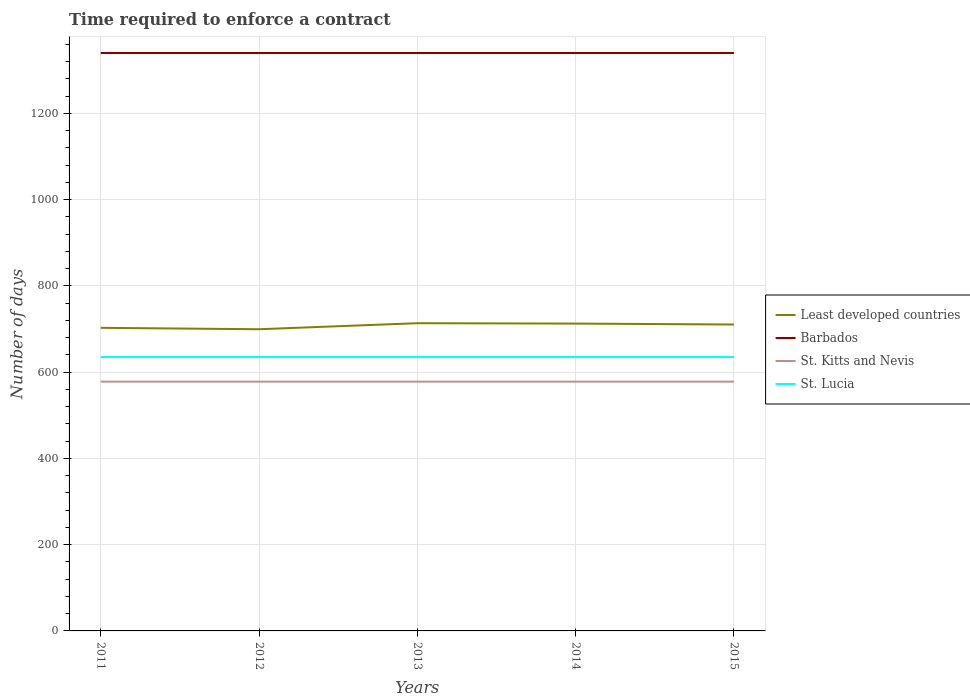How many different coloured lines are there?
Ensure brevity in your answer.  4. Does the line corresponding to St. Lucia intersect with the line corresponding to St. Kitts and Nevis?
Provide a succinct answer. No. Is the number of lines equal to the number of legend labels?
Offer a very short reply. Yes. Across all years, what is the maximum number of days required to enforce a contract in St. Lucia?
Your answer should be very brief. 635. In which year was the number of days required to enforce a contract in St. Lucia maximum?
Provide a short and direct response. 2011. What is the difference between the highest and the second highest number of days required to enforce a contract in St. Kitts and Nevis?
Your answer should be compact. 0. What is the difference between the highest and the lowest number of days required to enforce a contract in St. Lucia?
Offer a terse response. 0. Is the number of days required to enforce a contract in Barbados strictly greater than the number of days required to enforce a contract in St. Kitts and Nevis over the years?
Make the answer very short. No. How many lines are there?
Offer a terse response. 4. How many years are there in the graph?
Your response must be concise. 5. Are the values on the major ticks of Y-axis written in scientific E-notation?
Make the answer very short. No. Does the graph contain grids?
Offer a terse response. Yes. How many legend labels are there?
Offer a terse response. 4. How are the legend labels stacked?
Make the answer very short. Vertical. What is the title of the graph?
Make the answer very short. Time required to enforce a contract. Does "Lesotho" appear as one of the legend labels in the graph?
Make the answer very short. No. What is the label or title of the X-axis?
Give a very brief answer. Years. What is the label or title of the Y-axis?
Make the answer very short. Number of days. What is the Number of days of Least developed countries in 2011?
Your response must be concise. 702.79. What is the Number of days of Barbados in 2011?
Offer a very short reply. 1340. What is the Number of days in St. Kitts and Nevis in 2011?
Provide a short and direct response. 578. What is the Number of days of St. Lucia in 2011?
Ensure brevity in your answer.  635. What is the Number of days in Least developed countries in 2012?
Your response must be concise. 699.53. What is the Number of days in Barbados in 2012?
Provide a short and direct response. 1340. What is the Number of days in St. Kitts and Nevis in 2012?
Make the answer very short. 578. What is the Number of days of St. Lucia in 2012?
Offer a terse response. 635. What is the Number of days in Least developed countries in 2013?
Your answer should be compact. 713.5. What is the Number of days of Barbados in 2013?
Provide a succinct answer. 1340. What is the Number of days in St. Kitts and Nevis in 2013?
Your response must be concise. 578. What is the Number of days of St. Lucia in 2013?
Make the answer very short. 635. What is the Number of days of Least developed countries in 2014?
Offer a terse response. 712.63. What is the Number of days in Barbados in 2014?
Provide a succinct answer. 1340. What is the Number of days in St. Kitts and Nevis in 2014?
Give a very brief answer. 578. What is the Number of days in St. Lucia in 2014?
Ensure brevity in your answer.  635. What is the Number of days of Least developed countries in 2015?
Keep it short and to the point. 710.46. What is the Number of days in Barbados in 2015?
Offer a very short reply. 1340. What is the Number of days in St. Kitts and Nevis in 2015?
Your response must be concise. 578. What is the Number of days in St. Lucia in 2015?
Give a very brief answer. 635. Across all years, what is the maximum Number of days of Least developed countries?
Ensure brevity in your answer.  713.5. Across all years, what is the maximum Number of days of Barbados?
Give a very brief answer. 1340. Across all years, what is the maximum Number of days of St. Kitts and Nevis?
Give a very brief answer. 578. Across all years, what is the maximum Number of days of St. Lucia?
Give a very brief answer. 635. Across all years, what is the minimum Number of days in Least developed countries?
Give a very brief answer. 699.53. Across all years, what is the minimum Number of days of Barbados?
Provide a short and direct response. 1340. Across all years, what is the minimum Number of days in St. Kitts and Nevis?
Provide a short and direct response. 578. Across all years, what is the minimum Number of days in St. Lucia?
Your answer should be very brief. 635. What is the total Number of days of Least developed countries in the graph?
Ensure brevity in your answer.  3538.91. What is the total Number of days of Barbados in the graph?
Make the answer very short. 6700. What is the total Number of days of St. Kitts and Nevis in the graph?
Offer a very short reply. 2890. What is the total Number of days of St. Lucia in the graph?
Your response must be concise. 3175. What is the difference between the Number of days of Least developed countries in 2011 and that in 2012?
Provide a succinct answer. 3.26. What is the difference between the Number of days in Least developed countries in 2011 and that in 2013?
Provide a succinct answer. -10.71. What is the difference between the Number of days in Barbados in 2011 and that in 2013?
Keep it short and to the point. 0. What is the difference between the Number of days of St. Kitts and Nevis in 2011 and that in 2013?
Make the answer very short. 0. What is the difference between the Number of days in Least developed countries in 2011 and that in 2014?
Provide a short and direct response. -9.84. What is the difference between the Number of days of Barbados in 2011 and that in 2014?
Provide a short and direct response. 0. What is the difference between the Number of days in St. Kitts and Nevis in 2011 and that in 2014?
Your response must be concise. 0. What is the difference between the Number of days of Least developed countries in 2011 and that in 2015?
Your response must be concise. -7.67. What is the difference between the Number of days in St. Lucia in 2011 and that in 2015?
Ensure brevity in your answer.  0. What is the difference between the Number of days in Least developed countries in 2012 and that in 2013?
Make the answer very short. -13.97. What is the difference between the Number of days in Barbados in 2012 and that in 2013?
Your response must be concise. 0. What is the difference between the Number of days of St. Kitts and Nevis in 2012 and that in 2013?
Ensure brevity in your answer.  0. What is the difference between the Number of days of Least developed countries in 2012 and that in 2014?
Provide a short and direct response. -13.1. What is the difference between the Number of days of Barbados in 2012 and that in 2014?
Make the answer very short. 0. What is the difference between the Number of days in Least developed countries in 2012 and that in 2015?
Offer a terse response. -10.92. What is the difference between the Number of days in St. Lucia in 2012 and that in 2015?
Offer a terse response. 0. What is the difference between the Number of days of Least developed countries in 2013 and that in 2014?
Offer a terse response. 0.87. What is the difference between the Number of days in Barbados in 2013 and that in 2014?
Provide a succinct answer. 0. What is the difference between the Number of days of Least developed countries in 2013 and that in 2015?
Keep it short and to the point. 3.04. What is the difference between the Number of days in St. Kitts and Nevis in 2013 and that in 2015?
Give a very brief answer. 0. What is the difference between the Number of days of Least developed countries in 2014 and that in 2015?
Ensure brevity in your answer.  2.17. What is the difference between the Number of days in Barbados in 2014 and that in 2015?
Make the answer very short. 0. What is the difference between the Number of days in St. Kitts and Nevis in 2014 and that in 2015?
Give a very brief answer. 0. What is the difference between the Number of days of Least developed countries in 2011 and the Number of days of Barbados in 2012?
Offer a very short reply. -637.21. What is the difference between the Number of days of Least developed countries in 2011 and the Number of days of St. Kitts and Nevis in 2012?
Make the answer very short. 124.79. What is the difference between the Number of days in Least developed countries in 2011 and the Number of days in St. Lucia in 2012?
Offer a very short reply. 67.79. What is the difference between the Number of days of Barbados in 2011 and the Number of days of St. Kitts and Nevis in 2012?
Keep it short and to the point. 762. What is the difference between the Number of days in Barbados in 2011 and the Number of days in St. Lucia in 2012?
Keep it short and to the point. 705. What is the difference between the Number of days in St. Kitts and Nevis in 2011 and the Number of days in St. Lucia in 2012?
Your answer should be very brief. -57. What is the difference between the Number of days of Least developed countries in 2011 and the Number of days of Barbados in 2013?
Your answer should be compact. -637.21. What is the difference between the Number of days of Least developed countries in 2011 and the Number of days of St. Kitts and Nevis in 2013?
Keep it short and to the point. 124.79. What is the difference between the Number of days of Least developed countries in 2011 and the Number of days of St. Lucia in 2013?
Keep it short and to the point. 67.79. What is the difference between the Number of days in Barbados in 2011 and the Number of days in St. Kitts and Nevis in 2013?
Offer a very short reply. 762. What is the difference between the Number of days of Barbados in 2011 and the Number of days of St. Lucia in 2013?
Your answer should be very brief. 705. What is the difference between the Number of days of St. Kitts and Nevis in 2011 and the Number of days of St. Lucia in 2013?
Your answer should be very brief. -57. What is the difference between the Number of days of Least developed countries in 2011 and the Number of days of Barbados in 2014?
Your answer should be very brief. -637.21. What is the difference between the Number of days in Least developed countries in 2011 and the Number of days in St. Kitts and Nevis in 2014?
Make the answer very short. 124.79. What is the difference between the Number of days of Least developed countries in 2011 and the Number of days of St. Lucia in 2014?
Ensure brevity in your answer.  67.79. What is the difference between the Number of days in Barbados in 2011 and the Number of days in St. Kitts and Nevis in 2014?
Your answer should be very brief. 762. What is the difference between the Number of days in Barbados in 2011 and the Number of days in St. Lucia in 2014?
Your answer should be very brief. 705. What is the difference between the Number of days in St. Kitts and Nevis in 2011 and the Number of days in St. Lucia in 2014?
Your answer should be very brief. -57. What is the difference between the Number of days in Least developed countries in 2011 and the Number of days in Barbados in 2015?
Keep it short and to the point. -637.21. What is the difference between the Number of days of Least developed countries in 2011 and the Number of days of St. Kitts and Nevis in 2015?
Offer a terse response. 124.79. What is the difference between the Number of days of Least developed countries in 2011 and the Number of days of St. Lucia in 2015?
Keep it short and to the point. 67.79. What is the difference between the Number of days of Barbados in 2011 and the Number of days of St. Kitts and Nevis in 2015?
Your answer should be compact. 762. What is the difference between the Number of days of Barbados in 2011 and the Number of days of St. Lucia in 2015?
Your answer should be very brief. 705. What is the difference between the Number of days of St. Kitts and Nevis in 2011 and the Number of days of St. Lucia in 2015?
Your answer should be compact. -57. What is the difference between the Number of days in Least developed countries in 2012 and the Number of days in Barbados in 2013?
Give a very brief answer. -640.47. What is the difference between the Number of days in Least developed countries in 2012 and the Number of days in St. Kitts and Nevis in 2013?
Your answer should be very brief. 121.53. What is the difference between the Number of days of Least developed countries in 2012 and the Number of days of St. Lucia in 2013?
Provide a succinct answer. 64.53. What is the difference between the Number of days in Barbados in 2012 and the Number of days in St. Kitts and Nevis in 2013?
Ensure brevity in your answer.  762. What is the difference between the Number of days in Barbados in 2012 and the Number of days in St. Lucia in 2013?
Offer a very short reply. 705. What is the difference between the Number of days in St. Kitts and Nevis in 2012 and the Number of days in St. Lucia in 2013?
Your answer should be very brief. -57. What is the difference between the Number of days in Least developed countries in 2012 and the Number of days in Barbados in 2014?
Offer a terse response. -640.47. What is the difference between the Number of days in Least developed countries in 2012 and the Number of days in St. Kitts and Nevis in 2014?
Offer a very short reply. 121.53. What is the difference between the Number of days in Least developed countries in 2012 and the Number of days in St. Lucia in 2014?
Your answer should be compact. 64.53. What is the difference between the Number of days in Barbados in 2012 and the Number of days in St. Kitts and Nevis in 2014?
Your response must be concise. 762. What is the difference between the Number of days in Barbados in 2012 and the Number of days in St. Lucia in 2014?
Offer a terse response. 705. What is the difference between the Number of days in St. Kitts and Nevis in 2012 and the Number of days in St. Lucia in 2014?
Ensure brevity in your answer.  -57. What is the difference between the Number of days of Least developed countries in 2012 and the Number of days of Barbados in 2015?
Offer a very short reply. -640.47. What is the difference between the Number of days in Least developed countries in 2012 and the Number of days in St. Kitts and Nevis in 2015?
Offer a very short reply. 121.53. What is the difference between the Number of days of Least developed countries in 2012 and the Number of days of St. Lucia in 2015?
Your response must be concise. 64.53. What is the difference between the Number of days of Barbados in 2012 and the Number of days of St. Kitts and Nevis in 2015?
Offer a terse response. 762. What is the difference between the Number of days of Barbados in 2012 and the Number of days of St. Lucia in 2015?
Offer a terse response. 705. What is the difference between the Number of days in St. Kitts and Nevis in 2012 and the Number of days in St. Lucia in 2015?
Your response must be concise. -57. What is the difference between the Number of days of Least developed countries in 2013 and the Number of days of Barbados in 2014?
Offer a terse response. -626.5. What is the difference between the Number of days in Least developed countries in 2013 and the Number of days in St. Kitts and Nevis in 2014?
Provide a short and direct response. 135.5. What is the difference between the Number of days in Least developed countries in 2013 and the Number of days in St. Lucia in 2014?
Provide a short and direct response. 78.5. What is the difference between the Number of days of Barbados in 2013 and the Number of days of St. Kitts and Nevis in 2014?
Offer a very short reply. 762. What is the difference between the Number of days of Barbados in 2013 and the Number of days of St. Lucia in 2014?
Offer a very short reply. 705. What is the difference between the Number of days in St. Kitts and Nevis in 2013 and the Number of days in St. Lucia in 2014?
Your answer should be compact. -57. What is the difference between the Number of days in Least developed countries in 2013 and the Number of days in Barbados in 2015?
Your response must be concise. -626.5. What is the difference between the Number of days in Least developed countries in 2013 and the Number of days in St. Kitts and Nevis in 2015?
Offer a very short reply. 135.5. What is the difference between the Number of days in Least developed countries in 2013 and the Number of days in St. Lucia in 2015?
Offer a very short reply. 78.5. What is the difference between the Number of days in Barbados in 2013 and the Number of days in St. Kitts and Nevis in 2015?
Give a very brief answer. 762. What is the difference between the Number of days of Barbados in 2013 and the Number of days of St. Lucia in 2015?
Provide a short and direct response. 705. What is the difference between the Number of days in St. Kitts and Nevis in 2013 and the Number of days in St. Lucia in 2015?
Your answer should be compact. -57. What is the difference between the Number of days in Least developed countries in 2014 and the Number of days in Barbados in 2015?
Your answer should be very brief. -627.37. What is the difference between the Number of days in Least developed countries in 2014 and the Number of days in St. Kitts and Nevis in 2015?
Your answer should be very brief. 134.63. What is the difference between the Number of days of Least developed countries in 2014 and the Number of days of St. Lucia in 2015?
Your response must be concise. 77.63. What is the difference between the Number of days in Barbados in 2014 and the Number of days in St. Kitts and Nevis in 2015?
Offer a terse response. 762. What is the difference between the Number of days in Barbados in 2014 and the Number of days in St. Lucia in 2015?
Offer a very short reply. 705. What is the difference between the Number of days in St. Kitts and Nevis in 2014 and the Number of days in St. Lucia in 2015?
Keep it short and to the point. -57. What is the average Number of days of Least developed countries per year?
Your response must be concise. 707.78. What is the average Number of days of Barbados per year?
Offer a terse response. 1340. What is the average Number of days of St. Kitts and Nevis per year?
Make the answer very short. 578. What is the average Number of days of St. Lucia per year?
Provide a succinct answer. 635. In the year 2011, what is the difference between the Number of days of Least developed countries and Number of days of Barbados?
Ensure brevity in your answer.  -637.21. In the year 2011, what is the difference between the Number of days in Least developed countries and Number of days in St. Kitts and Nevis?
Your answer should be compact. 124.79. In the year 2011, what is the difference between the Number of days of Least developed countries and Number of days of St. Lucia?
Provide a short and direct response. 67.79. In the year 2011, what is the difference between the Number of days of Barbados and Number of days of St. Kitts and Nevis?
Ensure brevity in your answer.  762. In the year 2011, what is the difference between the Number of days of Barbados and Number of days of St. Lucia?
Your response must be concise. 705. In the year 2011, what is the difference between the Number of days in St. Kitts and Nevis and Number of days in St. Lucia?
Ensure brevity in your answer.  -57. In the year 2012, what is the difference between the Number of days in Least developed countries and Number of days in Barbados?
Your answer should be very brief. -640.47. In the year 2012, what is the difference between the Number of days in Least developed countries and Number of days in St. Kitts and Nevis?
Provide a succinct answer. 121.53. In the year 2012, what is the difference between the Number of days in Least developed countries and Number of days in St. Lucia?
Offer a very short reply. 64.53. In the year 2012, what is the difference between the Number of days in Barbados and Number of days in St. Kitts and Nevis?
Make the answer very short. 762. In the year 2012, what is the difference between the Number of days in Barbados and Number of days in St. Lucia?
Offer a terse response. 705. In the year 2012, what is the difference between the Number of days in St. Kitts and Nevis and Number of days in St. Lucia?
Your response must be concise. -57. In the year 2013, what is the difference between the Number of days in Least developed countries and Number of days in Barbados?
Offer a very short reply. -626.5. In the year 2013, what is the difference between the Number of days of Least developed countries and Number of days of St. Kitts and Nevis?
Provide a succinct answer. 135.5. In the year 2013, what is the difference between the Number of days of Least developed countries and Number of days of St. Lucia?
Make the answer very short. 78.5. In the year 2013, what is the difference between the Number of days in Barbados and Number of days in St. Kitts and Nevis?
Ensure brevity in your answer.  762. In the year 2013, what is the difference between the Number of days in Barbados and Number of days in St. Lucia?
Provide a succinct answer. 705. In the year 2013, what is the difference between the Number of days in St. Kitts and Nevis and Number of days in St. Lucia?
Make the answer very short. -57. In the year 2014, what is the difference between the Number of days in Least developed countries and Number of days in Barbados?
Your answer should be very brief. -627.37. In the year 2014, what is the difference between the Number of days in Least developed countries and Number of days in St. Kitts and Nevis?
Provide a short and direct response. 134.63. In the year 2014, what is the difference between the Number of days in Least developed countries and Number of days in St. Lucia?
Provide a short and direct response. 77.63. In the year 2014, what is the difference between the Number of days of Barbados and Number of days of St. Kitts and Nevis?
Offer a terse response. 762. In the year 2014, what is the difference between the Number of days of Barbados and Number of days of St. Lucia?
Give a very brief answer. 705. In the year 2014, what is the difference between the Number of days in St. Kitts and Nevis and Number of days in St. Lucia?
Ensure brevity in your answer.  -57. In the year 2015, what is the difference between the Number of days of Least developed countries and Number of days of Barbados?
Provide a short and direct response. -629.54. In the year 2015, what is the difference between the Number of days of Least developed countries and Number of days of St. Kitts and Nevis?
Offer a very short reply. 132.46. In the year 2015, what is the difference between the Number of days of Least developed countries and Number of days of St. Lucia?
Offer a terse response. 75.46. In the year 2015, what is the difference between the Number of days in Barbados and Number of days in St. Kitts and Nevis?
Provide a short and direct response. 762. In the year 2015, what is the difference between the Number of days in Barbados and Number of days in St. Lucia?
Give a very brief answer. 705. In the year 2015, what is the difference between the Number of days of St. Kitts and Nevis and Number of days of St. Lucia?
Your answer should be compact. -57. What is the ratio of the Number of days in St. Kitts and Nevis in 2011 to that in 2012?
Keep it short and to the point. 1. What is the ratio of the Number of days in St. Lucia in 2011 to that in 2012?
Your response must be concise. 1. What is the ratio of the Number of days of Least developed countries in 2011 to that in 2013?
Ensure brevity in your answer.  0.98. What is the ratio of the Number of days of Barbados in 2011 to that in 2013?
Offer a very short reply. 1. What is the ratio of the Number of days in Least developed countries in 2011 to that in 2014?
Your answer should be compact. 0.99. What is the ratio of the Number of days in St. Lucia in 2011 to that in 2014?
Provide a short and direct response. 1. What is the ratio of the Number of days of Barbados in 2011 to that in 2015?
Ensure brevity in your answer.  1. What is the ratio of the Number of days in Least developed countries in 2012 to that in 2013?
Make the answer very short. 0.98. What is the ratio of the Number of days of Barbados in 2012 to that in 2013?
Offer a very short reply. 1. What is the ratio of the Number of days in St. Lucia in 2012 to that in 2013?
Provide a short and direct response. 1. What is the ratio of the Number of days in Least developed countries in 2012 to that in 2014?
Provide a succinct answer. 0.98. What is the ratio of the Number of days in Barbados in 2012 to that in 2014?
Your answer should be compact. 1. What is the ratio of the Number of days in St. Lucia in 2012 to that in 2014?
Offer a terse response. 1. What is the ratio of the Number of days of Least developed countries in 2012 to that in 2015?
Ensure brevity in your answer.  0.98. What is the ratio of the Number of days of Barbados in 2012 to that in 2015?
Keep it short and to the point. 1. What is the ratio of the Number of days in St. Lucia in 2012 to that in 2015?
Your response must be concise. 1. What is the ratio of the Number of days in Least developed countries in 2013 to that in 2014?
Ensure brevity in your answer.  1. What is the ratio of the Number of days in St. Kitts and Nevis in 2013 to that in 2014?
Provide a short and direct response. 1. What is the ratio of the Number of days in St. Lucia in 2013 to that in 2014?
Ensure brevity in your answer.  1. What is the ratio of the Number of days of Least developed countries in 2013 to that in 2015?
Your answer should be very brief. 1. What is the ratio of the Number of days in Barbados in 2013 to that in 2015?
Offer a very short reply. 1. What is the ratio of the Number of days in St. Kitts and Nevis in 2013 to that in 2015?
Make the answer very short. 1. What is the ratio of the Number of days in St. Lucia in 2013 to that in 2015?
Provide a succinct answer. 1. What is the ratio of the Number of days of Barbados in 2014 to that in 2015?
Offer a terse response. 1. What is the ratio of the Number of days in St. Lucia in 2014 to that in 2015?
Offer a terse response. 1. What is the difference between the highest and the second highest Number of days in Least developed countries?
Provide a succinct answer. 0.87. What is the difference between the highest and the second highest Number of days of Barbados?
Give a very brief answer. 0. What is the difference between the highest and the second highest Number of days of St. Kitts and Nevis?
Make the answer very short. 0. What is the difference between the highest and the second highest Number of days of St. Lucia?
Provide a short and direct response. 0. What is the difference between the highest and the lowest Number of days in Least developed countries?
Your response must be concise. 13.97. What is the difference between the highest and the lowest Number of days of St. Kitts and Nevis?
Your answer should be compact. 0. What is the difference between the highest and the lowest Number of days in St. Lucia?
Give a very brief answer. 0. 